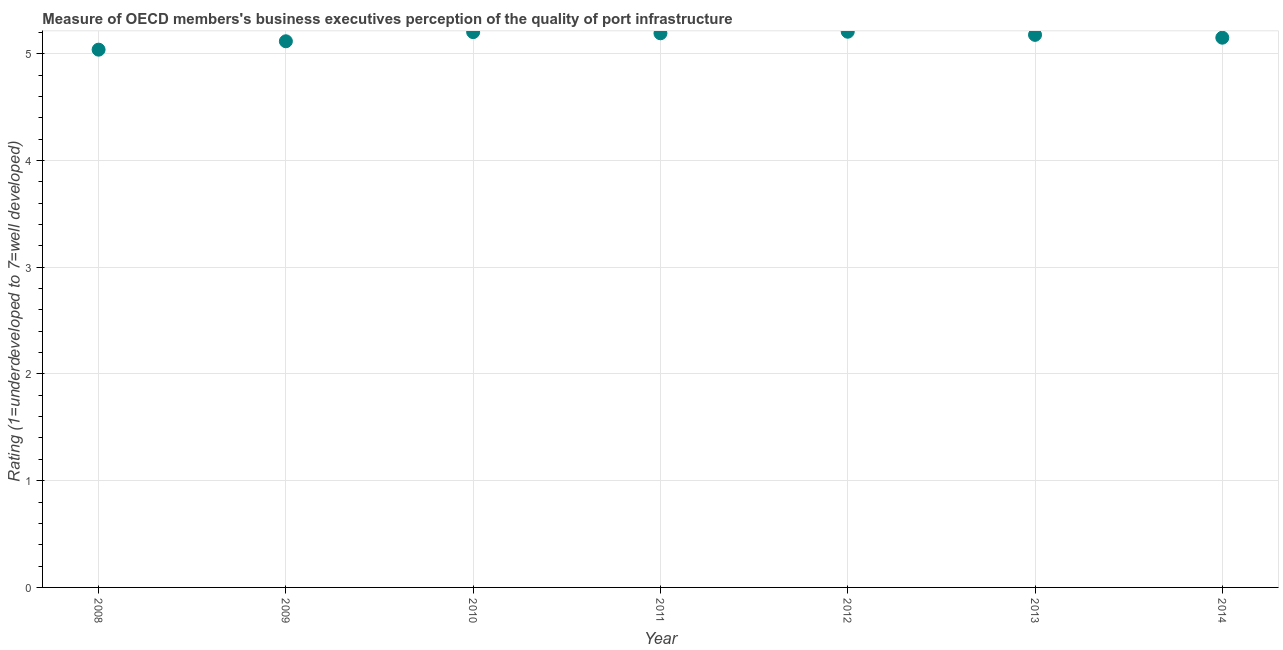What is the rating measuring quality of port infrastructure in 2011?
Give a very brief answer. 5.19. Across all years, what is the maximum rating measuring quality of port infrastructure?
Provide a succinct answer. 5.21. Across all years, what is the minimum rating measuring quality of port infrastructure?
Your response must be concise. 5.04. In which year was the rating measuring quality of port infrastructure maximum?
Your answer should be very brief. 2012. In which year was the rating measuring quality of port infrastructure minimum?
Keep it short and to the point. 2008. What is the sum of the rating measuring quality of port infrastructure?
Provide a succinct answer. 36.08. What is the difference between the rating measuring quality of port infrastructure in 2009 and 2013?
Give a very brief answer. -0.06. What is the average rating measuring quality of port infrastructure per year?
Offer a very short reply. 5.15. What is the median rating measuring quality of port infrastructure?
Offer a terse response. 5.18. Do a majority of the years between 2014 and 2008 (inclusive) have rating measuring quality of port infrastructure greater than 2.2 ?
Your answer should be very brief. Yes. What is the ratio of the rating measuring quality of port infrastructure in 2012 to that in 2014?
Your answer should be very brief. 1.01. Is the difference between the rating measuring quality of port infrastructure in 2010 and 2012 greater than the difference between any two years?
Ensure brevity in your answer.  No. What is the difference between the highest and the second highest rating measuring quality of port infrastructure?
Give a very brief answer. 0. Is the sum of the rating measuring quality of port infrastructure in 2009 and 2012 greater than the maximum rating measuring quality of port infrastructure across all years?
Your answer should be very brief. Yes. What is the difference between the highest and the lowest rating measuring quality of port infrastructure?
Keep it short and to the point. 0.17. Does the rating measuring quality of port infrastructure monotonically increase over the years?
Your answer should be very brief. No. How many dotlines are there?
Your answer should be compact. 1. Are the values on the major ticks of Y-axis written in scientific E-notation?
Your answer should be very brief. No. What is the title of the graph?
Offer a very short reply. Measure of OECD members's business executives perception of the quality of port infrastructure. What is the label or title of the X-axis?
Your response must be concise. Year. What is the label or title of the Y-axis?
Offer a terse response. Rating (1=underdeveloped to 7=well developed) . What is the Rating (1=underdeveloped to 7=well developed)  in 2008?
Make the answer very short. 5.04. What is the Rating (1=underdeveloped to 7=well developed)  in 2009?
Make the answer very short. 5.12. What is the Rating (1=underdeveloped to 7=well developed)  in 2010?
Ensure brevity in your answer.  5.2. What is the Rating (1=underdeveloped to 7=well developed)  in 2011?
Make the answer very short. 5.19. What is the Rating (1=underdeveloped to 7=well developed)  in 2012?
Your answer should be very brief. 5.21. What is the Rating (1=underdeveloped to 7=well developed)  in 2013?
Keep it short and to the point. 5.18. What is the Rating (1=underdeveloped to 7=well developed)  in 2014?
Keep it short and to the point. 5.15. What is the difference between the Rating (1=underdeveloped to 7=well developed)  in 2008 and 2009?
Offer a terse response. -0.08. What is the difference between the Rating (1=underdeveloped to 7=well developed)  in 2008 and 2010?
Give a very brief answer. -0.16. What is the difference between the Rating (1=underdeveloped to 7=well developed)  in 2008 and 2011?
Make the answer very short. -0.15. What is the difference between the Rating (1=underdeveloped to 7=well developed)  in 2008 and 2012?
Give a very brief answer. -0.17. What is the difference between the Rating (1=underdeveloped to 7=well developed)  in 2008 and 2013?
Your response must be concise. -0.14. What is the difference between the Rating (1=underdeveloped to 7=well developed)  in 2008 and 2014?
Your answer should be compact. -0.11. What is the difference between the Rating (1=underdeveloped to 7=well developed)  in 2009 and 2010?
Your response must be concise. -0.09. What is the difference between the Rating (1=underdeveloped to 7=well developed)  in 2009 and 2011?
Ensure brevity in your answer.  -0.07. What is the difference between the Rating (1=underdeveloped to 7=well developed)  in 2009 and 2012?
Provide a short and direct response. -0.09. What is the difference between the Rating (1=underdeveloped to 7=well developed)  in 2009 and 2013?
Provide a short and direct response. -0.06. What is the difference between the Rating (1=underdeveloped to 7=well developed)  in 2009 and 2014?
Your answer should be very brief. -0.03. What is the difference between the Rating (1=underdeveloped to 7=well developed)  in 2010 and 2011?
Ensure brevity in your answer.  0.01. What is the difference between the Rating (1=underdeveloped to 7=well developed)  in 2010 and 2012?
Provide a short and direct response. -0. What is the difference between the Rating (1=underdeveloped to 7=well developed)  in 2010 and 2013?
Your response must be concise. 0.03. What is the difference between the Rating (1=underdeveloped to 7=well developed)  in 2010 and 2014?
Ensure brevity in your answer.  0.05. What is the difference between the Rating (1=underdeveloped to 7=well developed)  in 2011 and 2012?
Keep it short and to the point. -0.01. What is the difference between the Rating (1=underdeveloped to 7=well developed)  in 2011 and 2013?
Provide a short and direct response. 0.01. What is the difference between the Rating (1=underdeveloped to 7=well developed)  in 2011 and 2014?
Keep it short and to the point. 0.04. What is the difference between the Rating (1=underdeveloped to 7=well developed)  in 2012 and 2013?
Provide a succinct answer. 0.03. What is the difference between the Rating (1=underdeveloped to 7=well developed)  in 2012 and 2014?
Your answer should be compact. 0.06. What is the difference between the Rating (1=underdeveloped to 7=well developed)  in 2013 and 2014?
Provide a short and direct response. 0.03. What is the ratio of the Rating (1=underdeveloped to 7=well developed)  in 2008 to that in 2010?
Your response must be concise. 0.97. What is the ratio of the Rating (1=underdeveloped to 7=well developed)  in 2008 to that in 2012?
Provide a succinct answer. 0.97. What is the ratio of the Rating (1=underdeveloped to 7=well developed)  in 2009 to that in 2011?
Your response must be concise. 0.99. What is the ratio of the Rating (1=underdeveloped to 7=well developed)  in 2009 to that in 2012?
Provide a short and direct response. 0.98. What is the ratio of the Rating (1=underdeveloped to 7=well developed)  in 2009 to that in 2013?
Ensure brevity in your answer.  0.99. What is the ratio of the Rating (1=underdeveloped to 7=well developed)  in 2010 to that in 2012?
Your response must be concise. 1. What is the ratio of the Rating (1=underdeveloped to 7=well developed)  in 2010 to that in 2013?
Ensure brevity in your answer.  1. What is the ratio of the Rating (1=underdeveloped to 7=well developed)  in 2010 to that in 2014?
Your response must be concise. 1.01. What is the ratio of the Rating (1=underdeveloped to 7=well developed)  in 2011 to that in 2012?
Your response must be concise. 1. What is the ratio of the Rating (1=underdeveloped to 7=well developed)  in 2011 to that in 2013?
Your response must be concise. 1. What is the ratio of the Rating (1=underdeveloped to 7=well developed)  in 2011 to that in 2014?
Give a very brief answer. 1.01. 